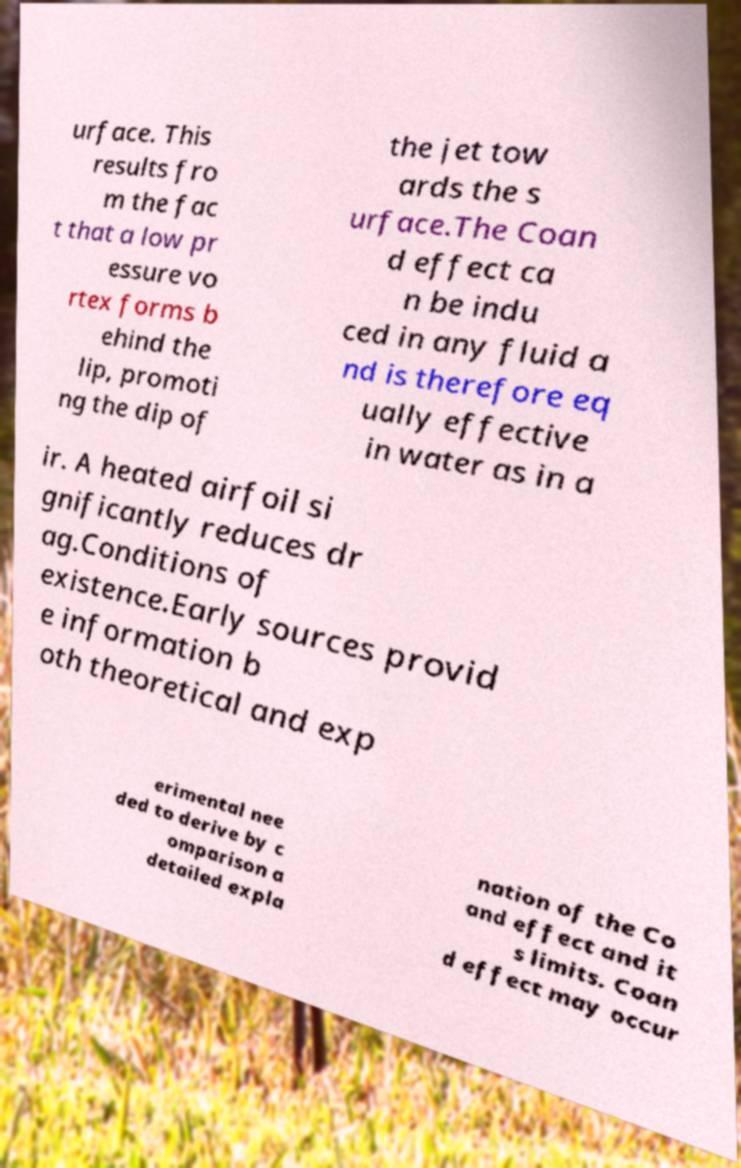Please read and relay the text visible in this image. What does it say? urface. This results fro m the fac t that a low pr essure vo rtex forms b ehind the lip, promoti ng the dip of the jet tow ards the s urface.The Coan d effect ca n be indu ced in any fluid a nd is therefore eq ually effective in water as in a ir. A heated airfoil si gnificantly reduces dr ag.Conditions of existence.Early sources provid e information b oth theoretical and exp erimental nee ded to derive by c omparison a detailed expla nation of the Co and effect and it s limits. Coan d effect may occur 